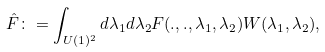Convert formula to latex. <formula><loc_0><loc_0><loc_500><loc_500>\hat { F } \colon = \int _ { U ( 1 ) ^ { 2 } } d \lambda _ { 1 } d \lambda _ { 2 } F ( . , . , \lambda _ { 1 } , \lambda _ { 2 } ) W ( \lambda _ { 1 } , \lambda _ { 2 } ) ,</formula> 